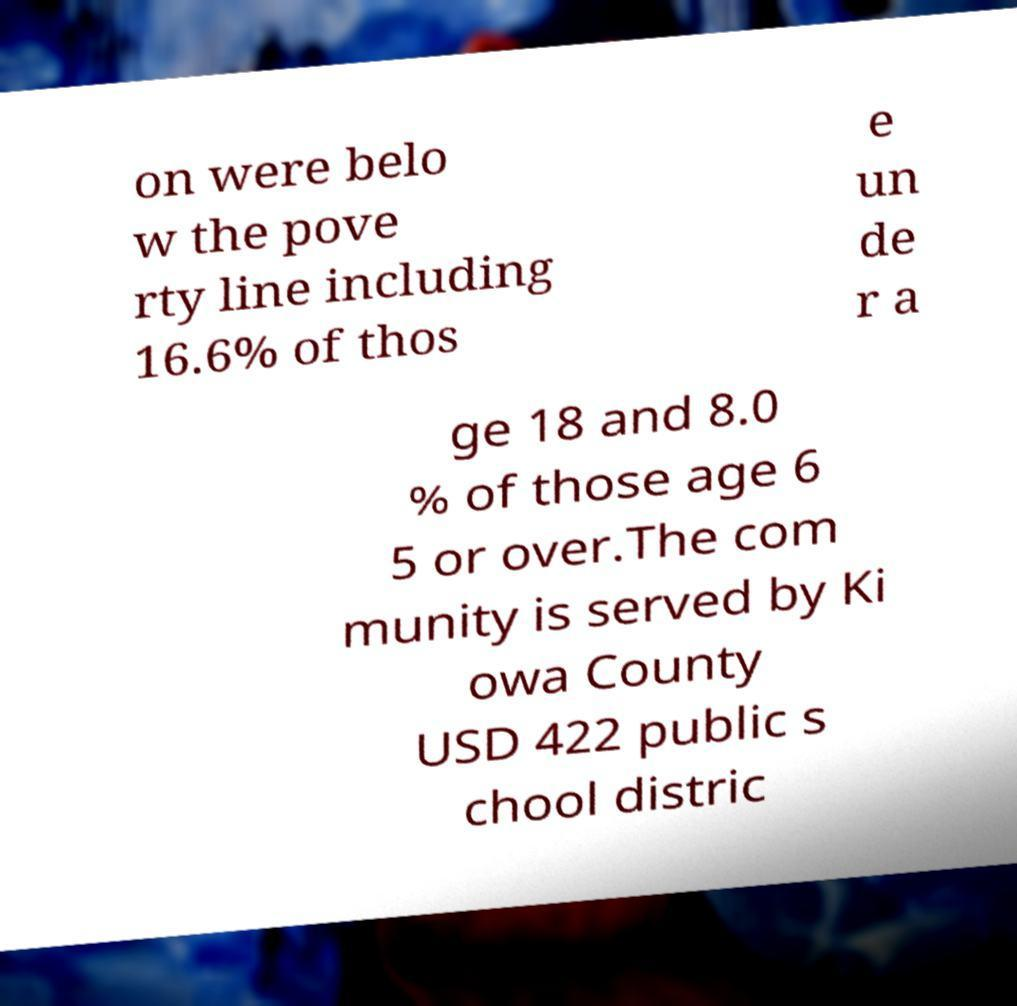Could you extract and type out the text from this image? on were belo w the pove rty line including 16.6% of thos e un de r a ge 18 and 8.0 % of those age 6 5 or over.The com munity is served by Ki owa County USD 422 public s chool distric 